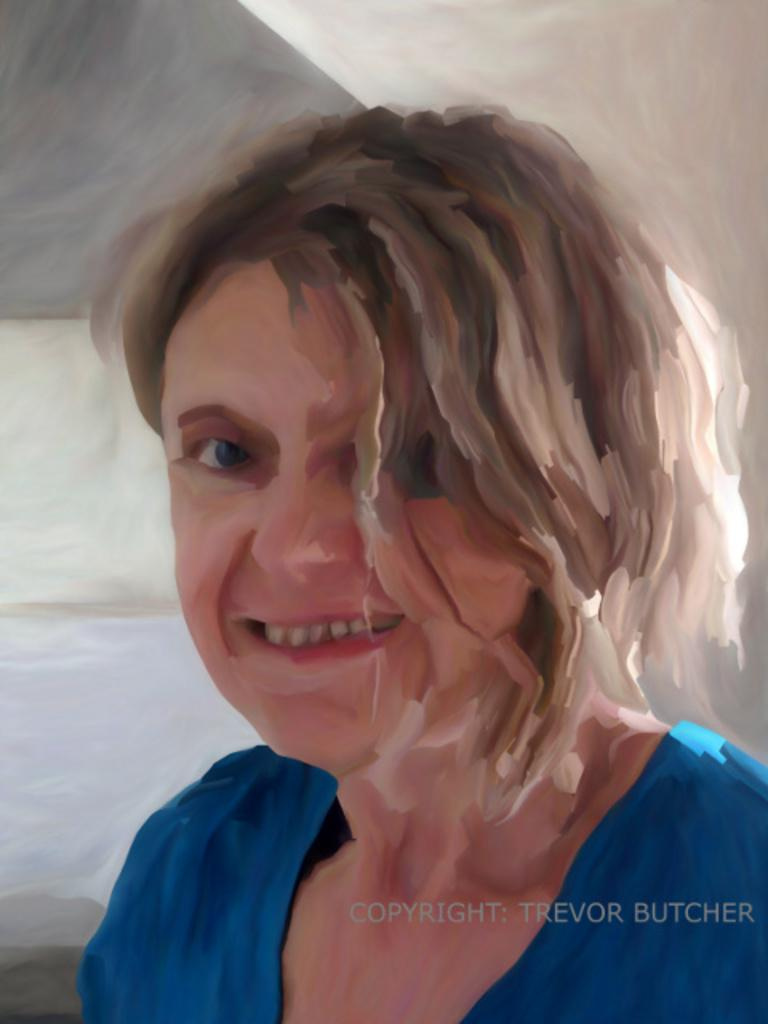What type of artwork is depicted in the image? The image is a painting. Who or what is the main subject of the painting? There is a woman in the painting. What expression does the woman have in the painting? The woman is smiling. What type of glue is being used by the woman in the painting? There is no glue present in the painting, as it features a woman who is smiling. What station is the woman in the painting traveling to? There is no indication of the woman traveling to a station in the painting, as it only shows her smiling. 